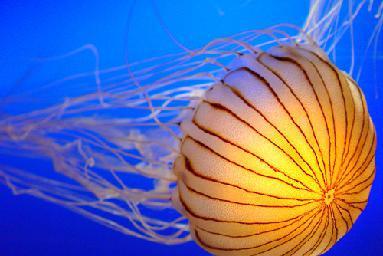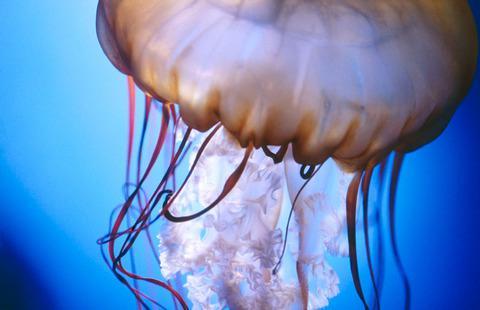The first image is the image on the left, the second image is the image on the right. Given the left and right images, does the statement "One of the jellyfish is heading in a horizontal direction." hold true? Answer yes or no. Yes. The first image is the image on the left, the second image is the image on the right. Considering the images on both sides, is "Each image contains one jellyfish with an orange 'cap', and the lefthand jellyfish has an upright 'cap' with tentacles trailing downward." valid? Answer yes or no. No. 